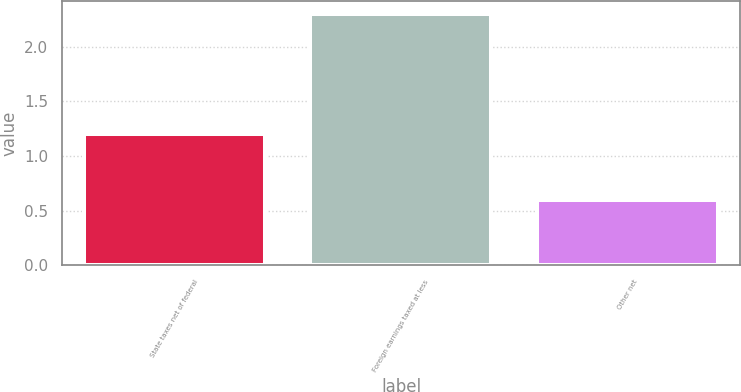<chart> <loc_0><loc_0><loc_500><loc_500><bar_chart><fcel>State taxes net of federal<fcel>Foreign earnings taxed at less<fcel>Other net<nl><fcel>1.2<fcel>2.3<fcel>0.6<nl></chart> 